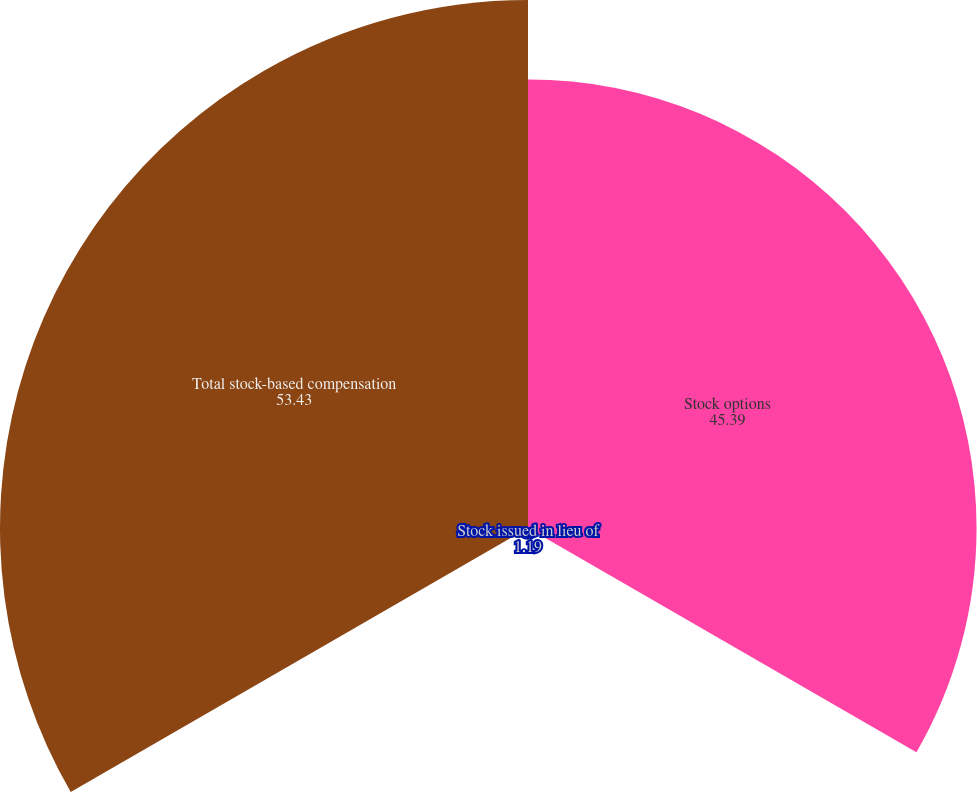<chart> <loc_0><loc_0><loc_500><loc_500><pie_chart><fcel>Stock options<fcel>Stock issued in lieu of<fcel>Total stock-based compensation<nl><fcel>45.39%<fcel>1.19%<fcel>53.43%<nl></chart> 